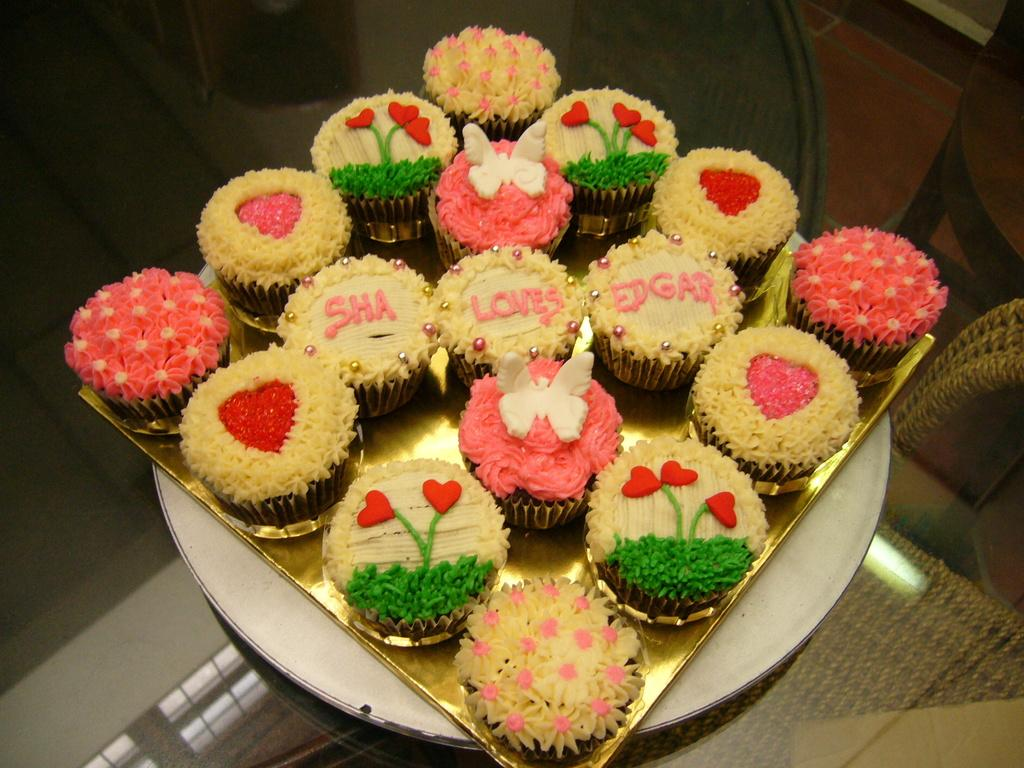What type of food is visible in the image? There are cupcakes in the image. How are the cupcakes arranged in the image? The cupcakes are in a tray. Where is the tray with cupcakes located in the image? The tray with cupcakes is placed on a table. What type of cheese is being cut in the image? There is no cheese present in the image; it features cupcakes in a tray on a table. 